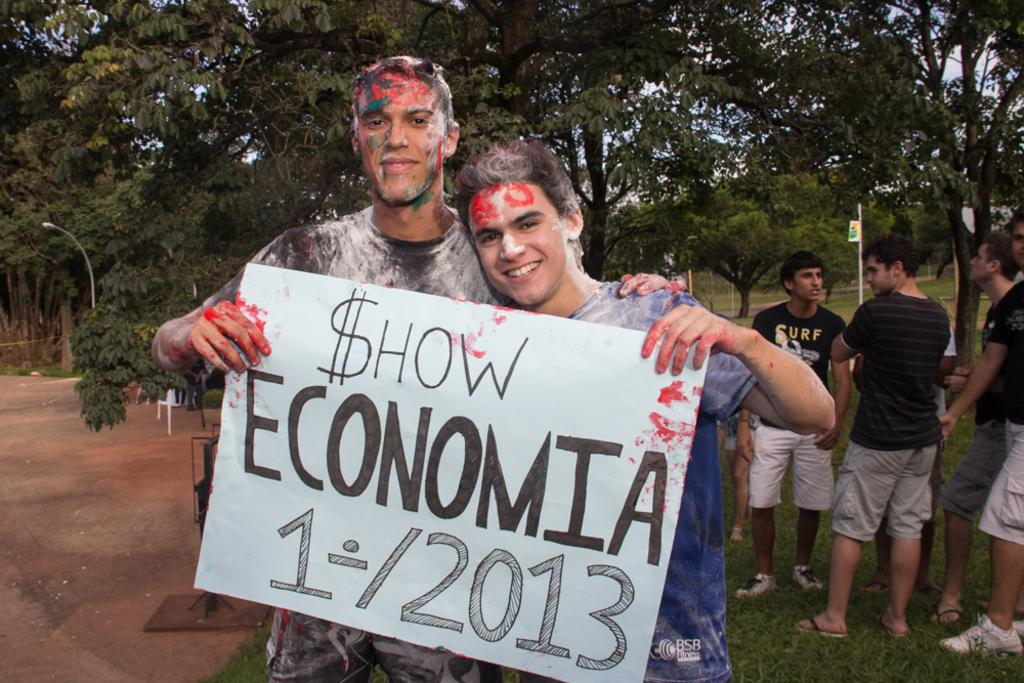What are the two persons holding in the image? The two persons are holding a chart with text in the image. Can you describe the other people visible in the image? There are other persons visible in the image, but their specific actions or interactions are not clear. What type of natural elements can be seen in the image? There are trees in the image. What man-made structures are present in the image? There are poles and a streetlight in the image. What type of furniture is visible in the image? There is a chair in the image. What effect does the chart have on the carpenter in the image? There is no carpenter present in the image, and therefore no such effect can be observed. What time of day is depicted in the image, based on the hour? The provided facts do not mention the time of day or any specific hour, so it cannot be determined from the image. 